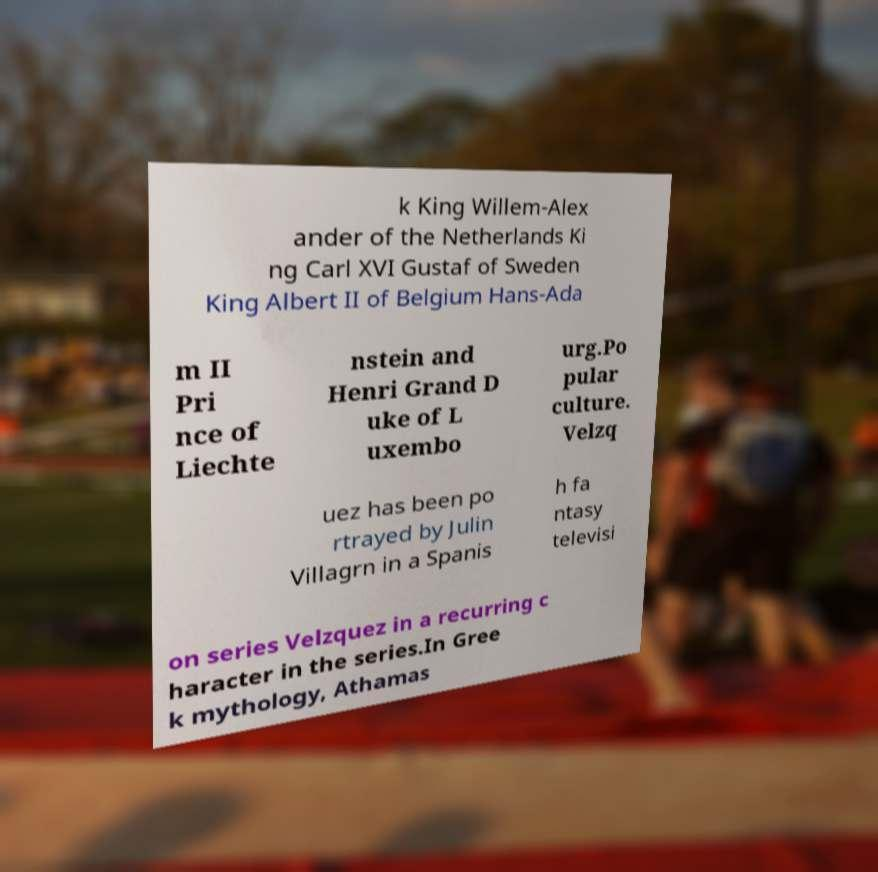Can you read and provide the text displayed in the image?This photo seems to have some interesting text. Can you extract and type it out for me? k King Willem-Alex ander of the Netherlands Ki ng Carl XVI Gustaf of Sweden King Albert II of Belgium Hans-Ada m II Pri nce of Liechte nstein and Henri Grand D uke of L uxembo urg.Po pular culture. Velzq uez has been po rtrayed by Julin Villagrn in a Spanis h fa ntasy televisi on series Velzquez in a recurring c haracter in the series.In Gree k mythology, Athamas 